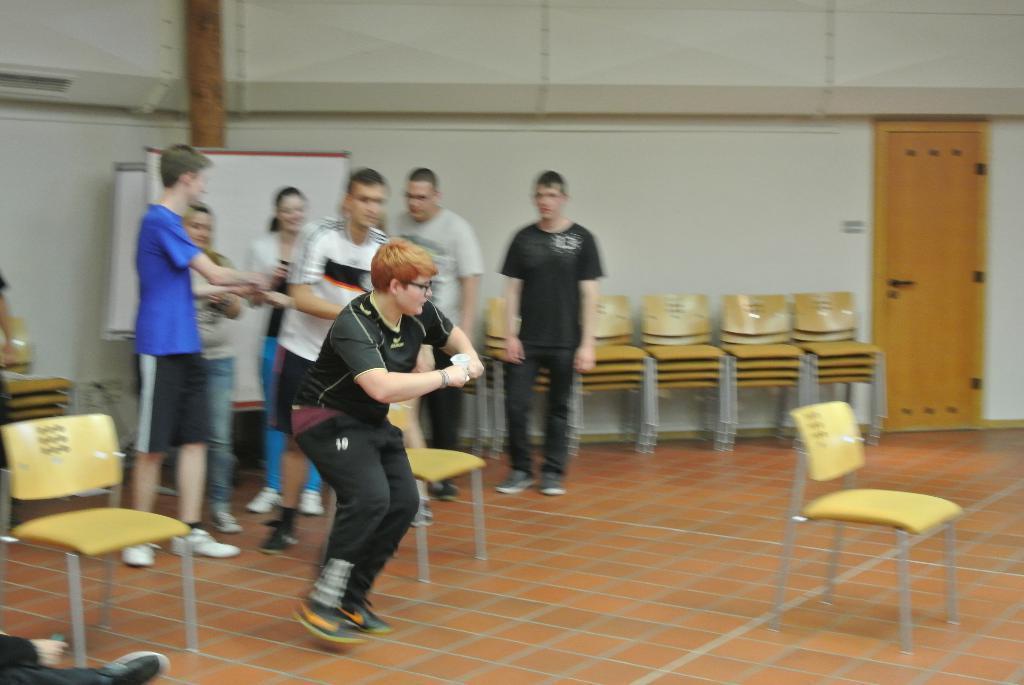Describe this image in one or two sentences. In this image I can see the wall, in front of the wall I can see white color board ,persons ,chairs , beam visible and i can see a person standing in the middle and back side of him I can see three chairs visible on the floor. And on the right side I can see a door, in the bottom left I can see a person hand and leg. 